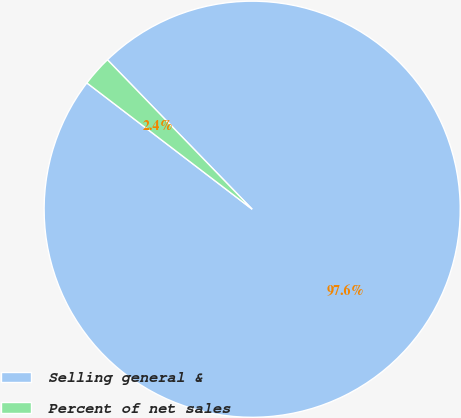<chart> <loc_0><loc_0><loc_500><loc_500><pie_chart><fcel>Selling general &<fcel>Percent of net sales<nl><fcel>97.63%<fcel>2.37%<nl></chart> 